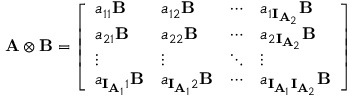<formula> <loc_0><loc_0><loc_500><loc_500>A \otimes B = \left [ \begin{array} { l l l l } { a _ { 1 1 } B } & { a _ { 1 2 } B } & { \cdots } & { a _ { 1 I _ { { A } _ { 2 } } } B } \\ { a _ { 2 1 } B } & { a _ { 2 2 } B } & { \cdots } & { a _ { 2 I _ { { A } _ { 2 } } } B } \\ { \vdots } & { \vdots } & { \ddots } & { \vdots } \\ { a _ { I _ { { A } _ { 1 } } 1 } B } & { a _ { I _ { { A } _ { 1 } } 2 } B } & { \cdots } & { a _ { I _ { { A } _ { 1 } } I _ { { A } _ { 2 } } } B } \end{array} \right ]</formula> 